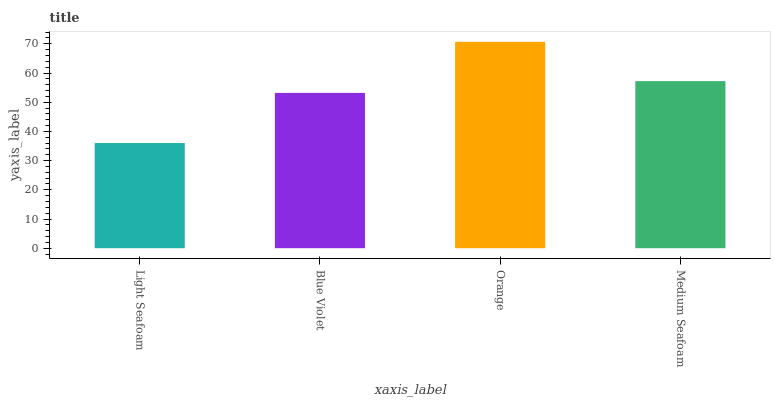Is Light Seafoam the minimum?
Answer yes or no. Yes. Is Orange the maximum?
Answer yes or no. Yes. Is Blue Violet the minimum?
Answer yes or no. No. Is Blue Violet the maximum?
Answer yes or no. No. Is Blue Violet greater than Light Seafoam?
Answer yes or no. Yes. Is Light Seafoam less than Blue Violet?
Answer yes or no. Yes. Is Light Seafoam greater than Blue Violet?
Answer yes or no. No. Is Blue Violet less than Light Seafoam?
Answer yes or no. No. Is Medium Seafoam the high median?
Answer yes or no. Yes. Is Blue Violet the low median?
Answer yes or no. Yes. Is Blue Violet the high median?
Answer yes or no. No. Is Orange the low median?
Answer yes or no. No. 